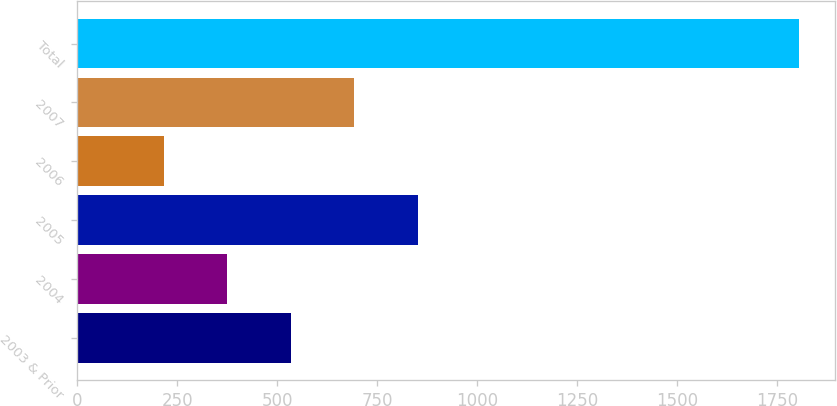Convert chart to OTSL. <chart><loc_0><loc_0><loc_500><loc_500><bar_chart><fcel>2003 & Prior<fcel>2004<fcel>2005<fcel>2006<fcel>2007<fcel>Total<nl><fcel>534<fcel>375.35<fcel>851.3<fcel>216.7<fcel>692.65<fcel>1803.2<nl></chart> 